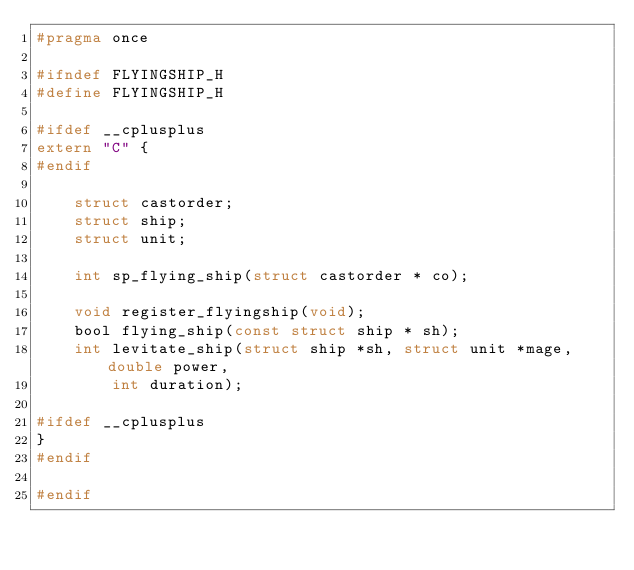<code> <loc_0><loc_0><loc_500><loc_500><_C_>#pragma once

#ifndef FLYINGSHIP_H
#define FLYINGSHIP_H

#ifdef __cplusplus
extern "C" {
#endif

    struct castorder;
    struct ship;
    struct unit;

    int sp_flying_ship(struct castorder * co);

    void register_flyingship(void);
    bool flying_ship(const struct ship * sh);
    int levitate_ship(struct ship *sh, struct unit *mage, double power,
        int duration);

#ifdef __cplusplus
}
#endif

#endif</code> 